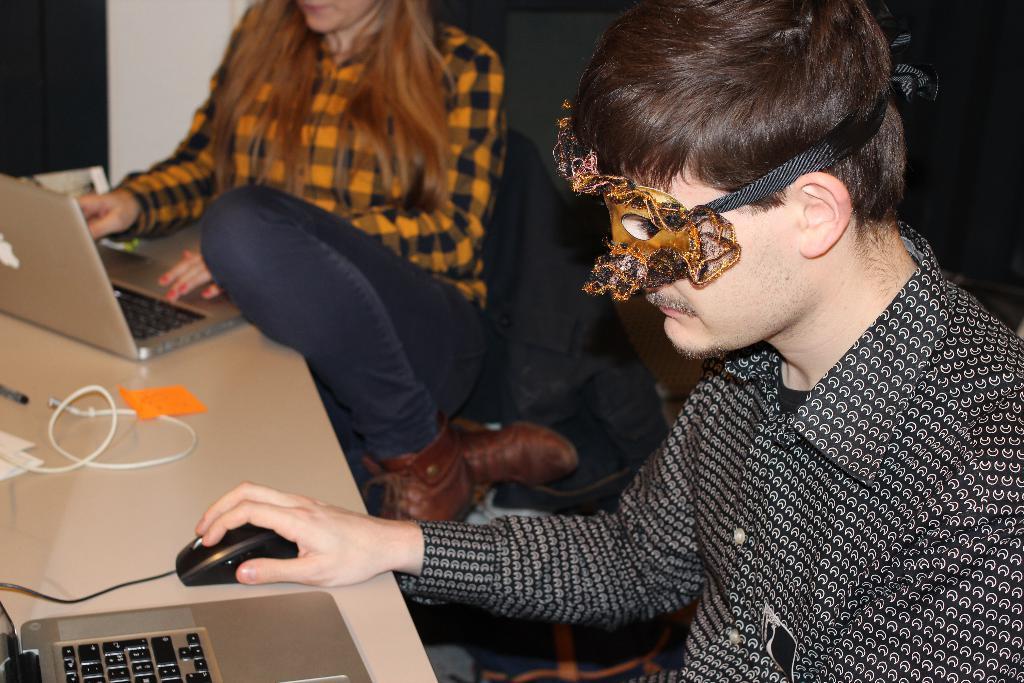Could you give a brief overview of what you see in this image? In this image there are two people sitting on chairs, in front of them there is a table, on that table there are laptops, wires, in the background there is a wall. 